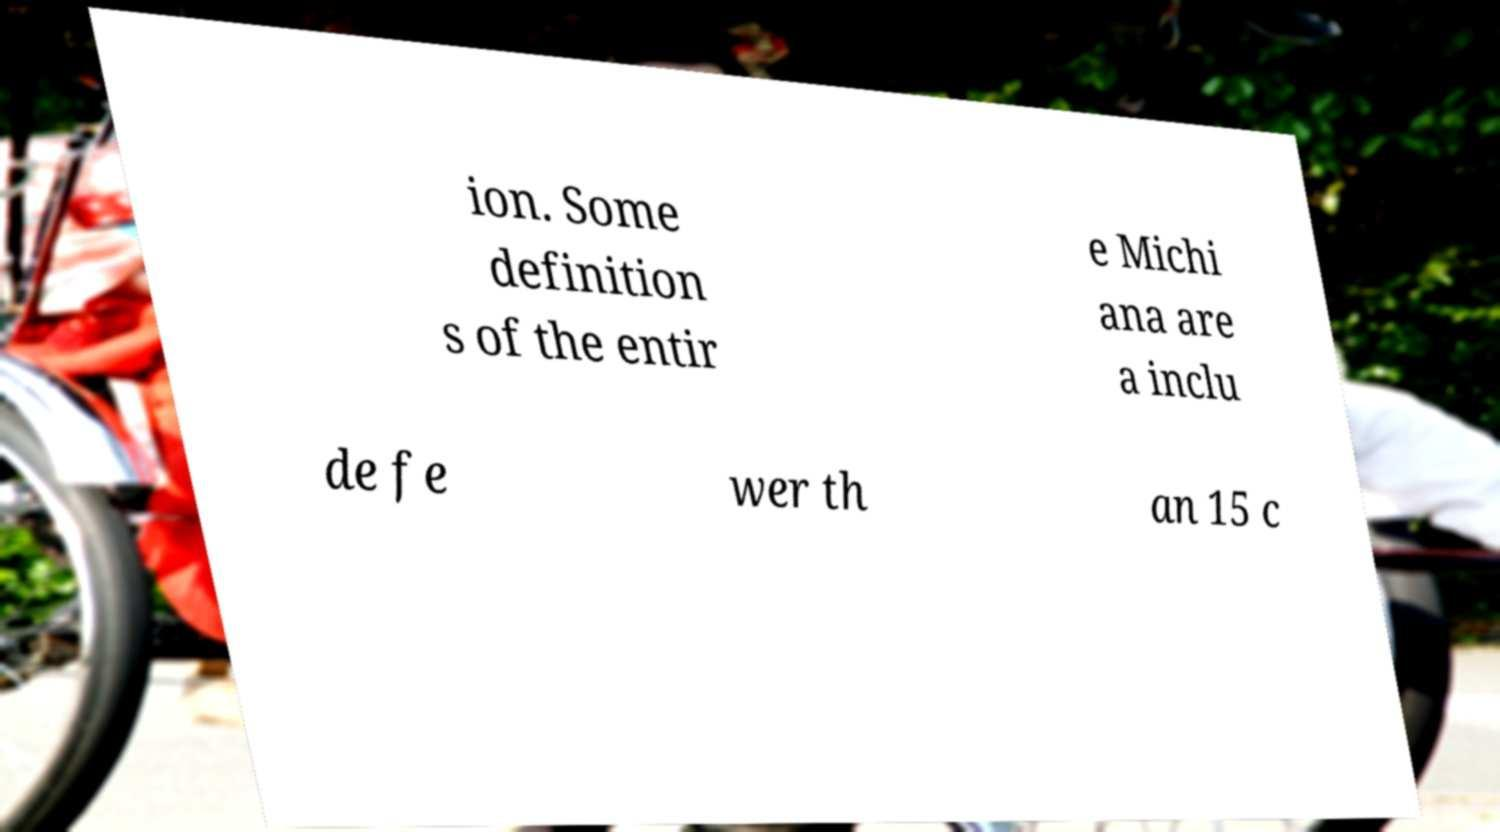For documentation purposes, I need the text within this image transcribed. Could you provide that? ion. Some definition s of the entir e Michi ana are a inclu de fe wer th an 15 c 